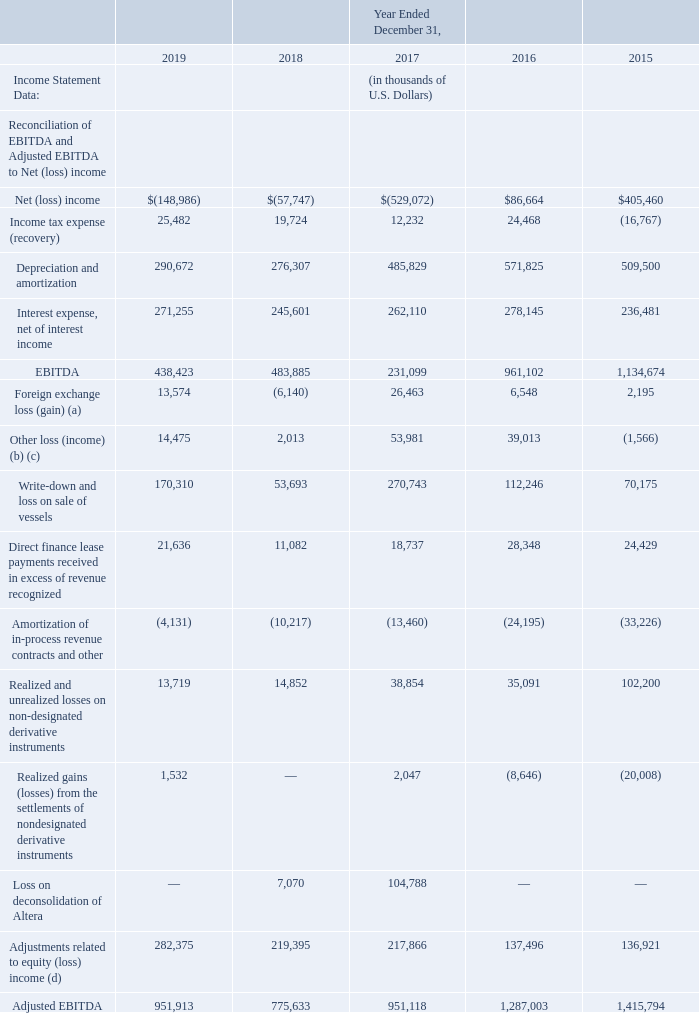The following table reconciles our historical consolidated EBITDA and Adjusted EBITDA to net (loss) income.
(a) Foreign currency exchange loss (gain) includes the unrealized loss of $13.2 million in 2019 (2018 – gain of $21.2 million, 2017 – gain of $82.7 million, 2016 – gain of $75.0 million, and 2015 – loss of $89.2 million) on cross currency swaps.
(b) In June 2016, as part of its financing initiatives, Altera canceled the construction contracts for its two UMS newbuildings. As a result, Altera accrued for potential damages resulting from the cancellations and reversed contingent liabilities previously recorded that were relating to the delivery of the UMS newbuildings.
This net loss provision of $23.4 million for the year ended December 31, 2016 was reported in other loss in our consolidated statement of income. The newbuilding contracts were held in Altera's separate subsidiaries and obligations of these subsidiaries were non-recourse to Altera.
(c) During the year ended December 31, 2016, the Company recorded a write-down of a cost-accounted investment of $19.0 million. This investment was subsequently sold in 2017, resulting in a gain on sale of $1.3 million. During 2017, the Company recognized an additional tax indemnification guarantee liability of $50 million related to the Teekay Nakilat finance leases. For additional information, please read "Item 18 – Financial Statements: Note 15 – Other loss".
(d) Adjustments related to equity (loss) income is a non-GAAP financial measure and should not be considered as an alternative to equity income or any other measure of financial performance or liquidity presented in accordance with GAAP. Adjustments related to equity (loss) income exclude some, but not all, items that affect equity (loss) income, and these measures may vary among other companies. Therefore, adjustments related to equity (loss) income as presented in this Annual Report may not be comparable to similarly titled measures of other companies.
Adjustments related to equity (loss) income includes depreciation and amortization, net interest expense, income tax expense (recovery), amortization of in-process revenue contracts, direct finance and salestype lease payments received in excess of revenue recognized, write-down and loss (gain) on sales of vessels, realized and unrealized loss (gain) on derivative instruments and other items, realized loss (gain) on foreign currency forward contracts,
and write-down and gain on sale of equity-accounted investments, in each case related to our equity-accounted entities, on the basis of our ownership percentages of such entities.
When did Altera canceled the construction contracts for its two UMS newbuildings? In june 2016, as part of its financing initiatives, altera canceled the construction contracts for its two ums newbuildings. What is the increase/ (decrease) in Net (loss) income from Year Ended December 31, 2019 to December 31, 2018?
Answer scale should be: thousand. 148,986-57,747
Answer: 91239. What is the increase/ (decrease) in Income tax expense (recovery) from Year Ended December 31, 2019 to December 31, 2018?
Answer scale should be: thousand. 25,482-19,724
Answer: 5758. In which year did the company recorded a net loss? Locate and analyze net (loss) income in row 5
answer: 2019, 2018, 2017. What was the foreign exchange loss (gain) from 2015 to 2019? Unrealized loss of $13.2 million in 2019, (2018 – gain of $21.2 million, 2017 – gain of $82.7 million, 2016 – gain of $75.0 million, 2015 – loss of $89.2 million. What was the net loss provision in 2016? $23.4 million. 